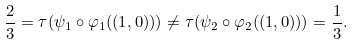Convert formula to latex. <formula><loc_0><loc_0><loc_500><loc_500>\frac { 2 } { 3 } = \tau ( \psi _ { 1 } \circ \varphi _ { 1 } ( ( 1 , 0 ) ) ) \neq \tau ( \psi _ { 2 } \circ \varphi _ { 2 } ( ( 1 , 0 ) ) ) = \frac { 1 } { 3 } .</formula> 